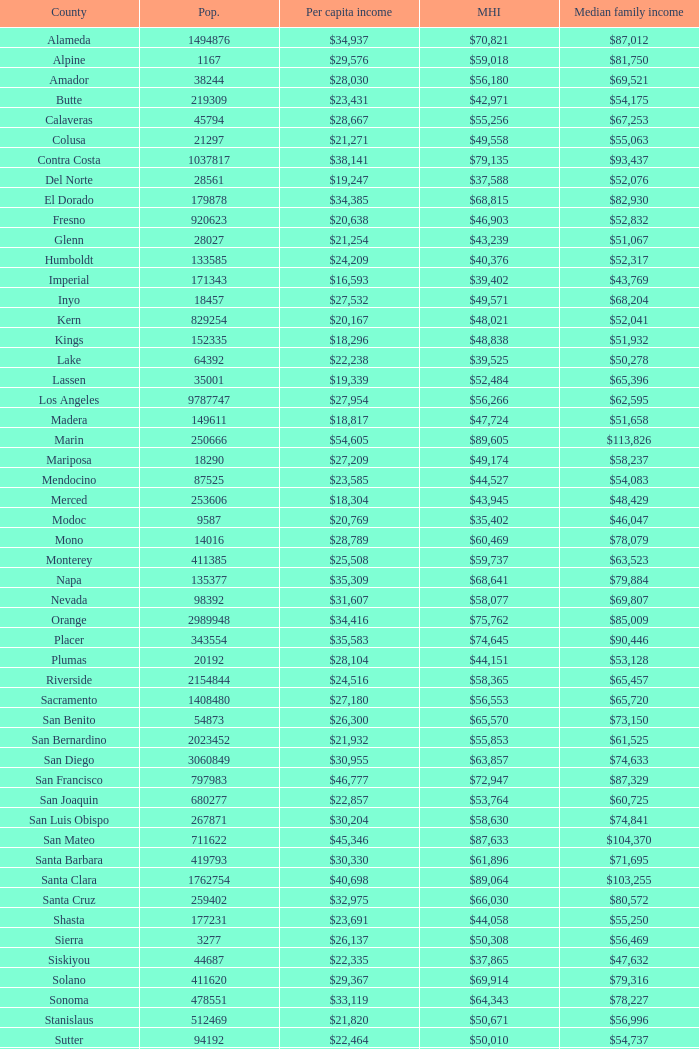What is the per capita income of shasta? $23,691. 